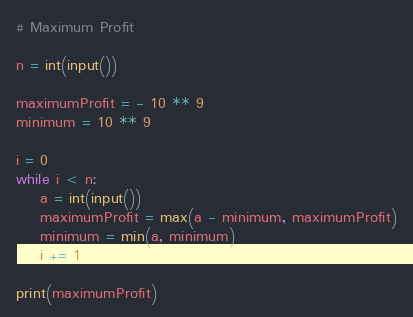<code> <loc_0><loc_0><loc_500><loc_500><_Python_># Maximum Profit

n = int(input())

maximumProfit = - 10 ** 9
minimum = 10 ** 9

i = 0
while i < n:
    a = int(input())
    maximumProfit = max(a - minimum, maximumProfit)
    minimum = min(a, minimum)
    i += 1

print(maximumProfit)

</code> 